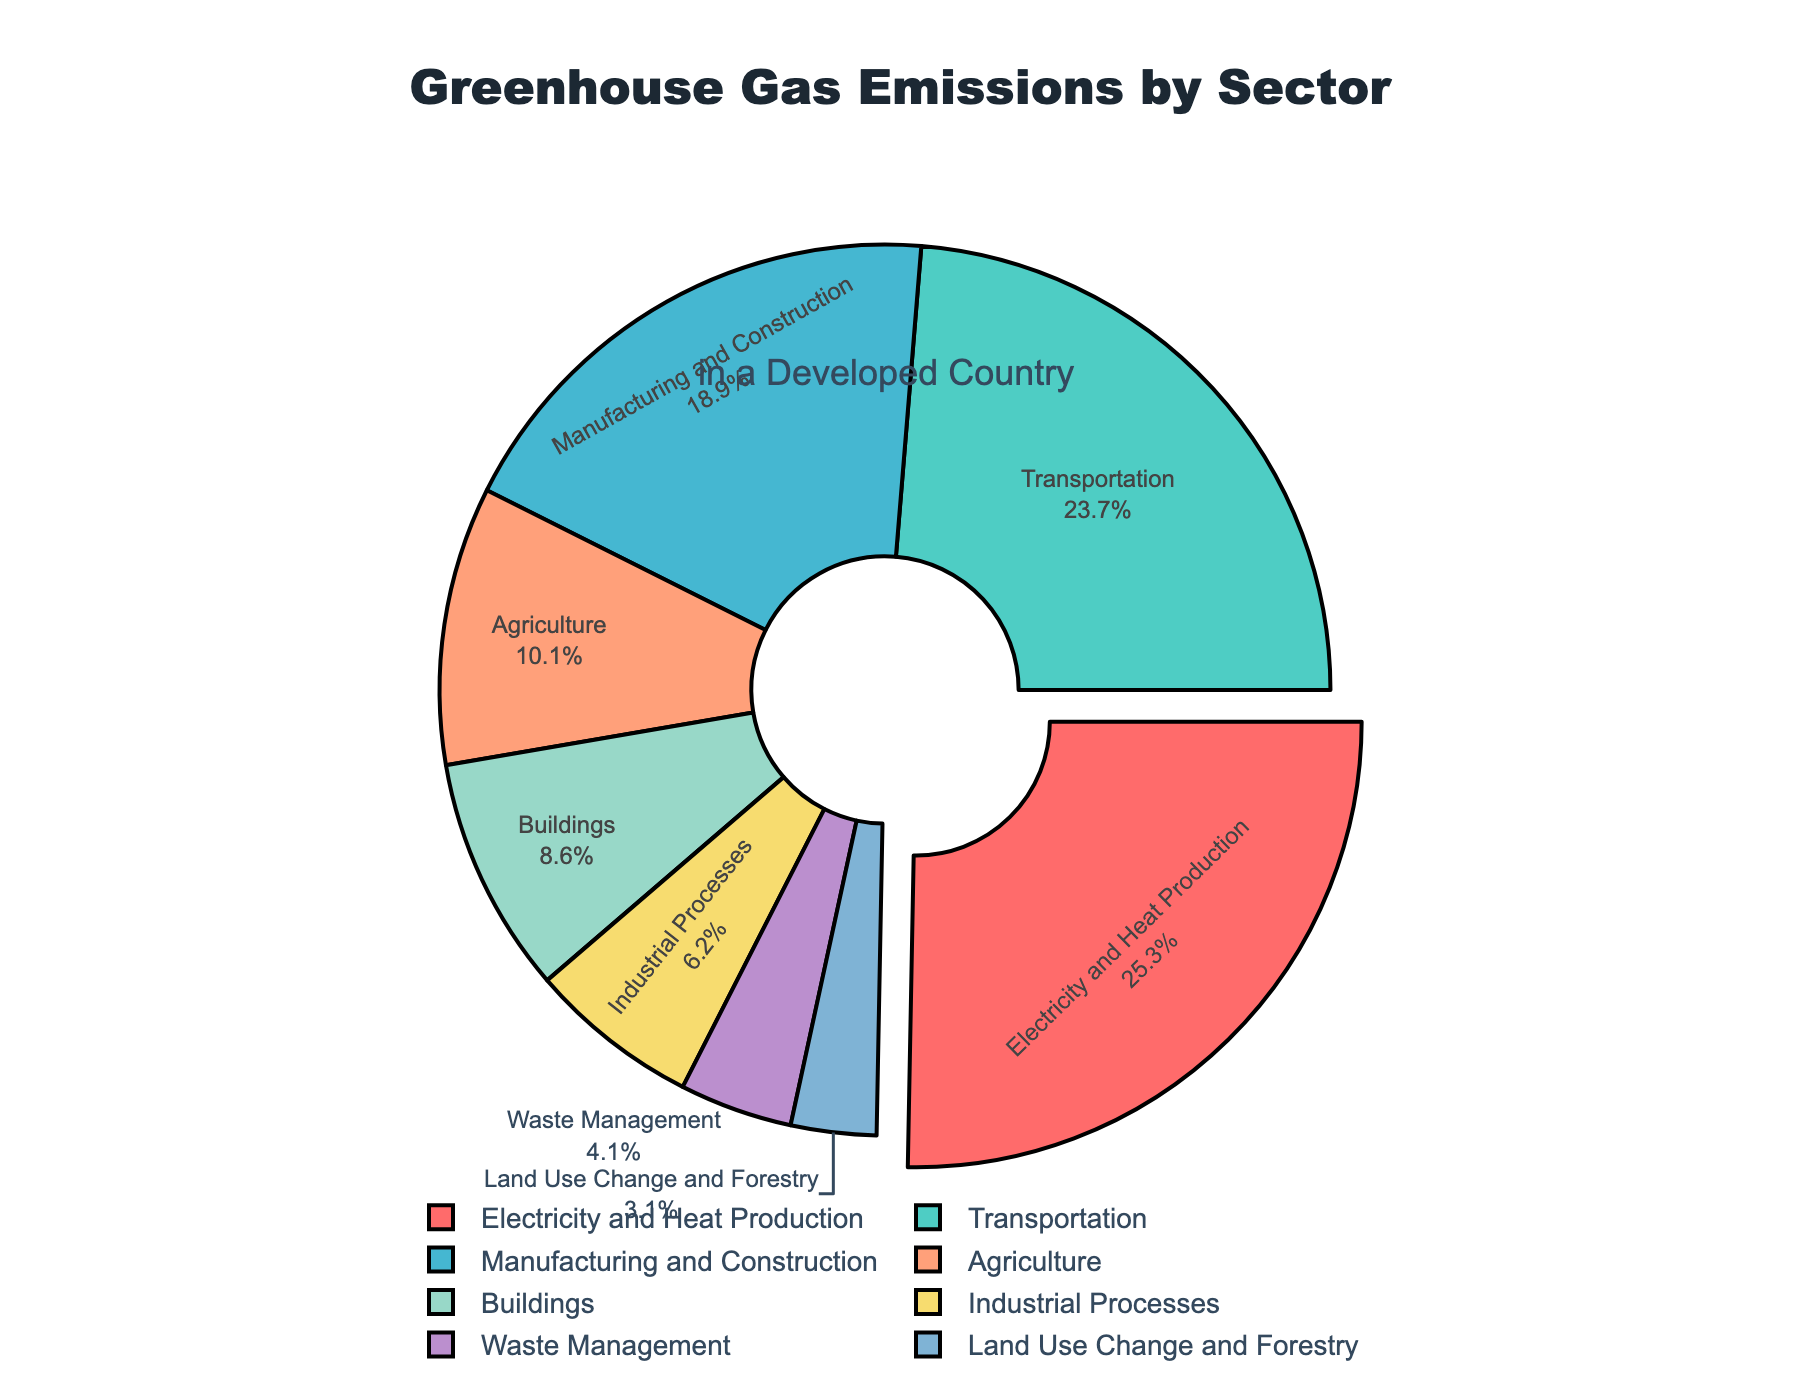What's the largest contributing sector to greenhouse gas emissions? The figure prominently pulls out the sector with the highest percentage, which makes it visually stand out. In the pie chart, the sector 'Electricity and Heat Production' is pulled out and has a percentage of 25.3%.
Answer: Electricity and Heat Production Which sector has the second highest greenhouse gas emissions? By referring to the sector percentages in the pie chart, the sector with the second highest emissions is 'Transportation' with a percentage of 23.7%.
Answer: Transportation What is the combined percentage of greenhouse gas emissions for Manufacturing and Construction, and Industrial Processes? Add the percentages for Manufacturing and Construction (18.9%) and Industrial Processes (6.2%): 18.9% + 6.2% = 25.1%.
Answer: 25.1% By how much does the Transportation sector exceed the Agriculture sector in terms of greenhouse gas emissions? Subtract the percentage of the Agriculture sector (10.1%) from the Transportation sector (23.7%): 23.7% - 10.1% = 13.6%.
Answer: 13.6% Are the combined emissions of Buildings and Waste Management lower or higher than the emissions of Agriculture? Add the percentages of Buildings (8.6%) and Waste Management (4.1%): 8.6% + 4.1% = 12.7%. Since 12.7% > 10.1%, the combined emissions of Buildings and Waste Management are higher.
Answer: Higher Which sector has the lowest greenhouse gas emissions, and what is its percentage? From the pie chart, the sector with the lowest emissions is 'Land Use Change and Forestry' with a percentage of 3.1%.
Answer: Land Use Change and Forestry, 3.1% What is the total percentage of greenhouse gas emissions from sectors below 10% individually? Sum the percentages of Agriculture (10.1%), Buildings (8.6%), Industrial Processes (6.2%), Waste Management (4.1%), and Land Use Change and Forestry (3.1%): 8.6% + 6.2% + 4.1% + 3.1% = 22.0%.
Answer: 22.0% Which sectors have emission percentages exceeding 20%? By observing the pie chart, the sectors that exceed 20% are Electricity and Heat Production (25.3%) and Transportation (23.7%).
Answer: Electricity and Heat Production, Transportation What is the difference in greenhouse gas emissions between the highest and lowest-emitting sectors? Subtract the percentage of the lowest-emitting sector (Land Use Change and Forestry, 3.1%) from the highest-emitting sector (Electricity and Heat Production, 25.3%): 25.3% - 3.1% = 22.2%.
Answer: 22.2% What's the total percentage of greenhouse gas emissions from the top three emitting sectors? Sum the percentages of the top three sectors: Electricity and Heat Production (25.3%), Transportation (23.7%), and Manufacturing and Construction (18.9%): 25.3% + 23.7% + 18.9% = 67.9%.
Answer: 67.9% 